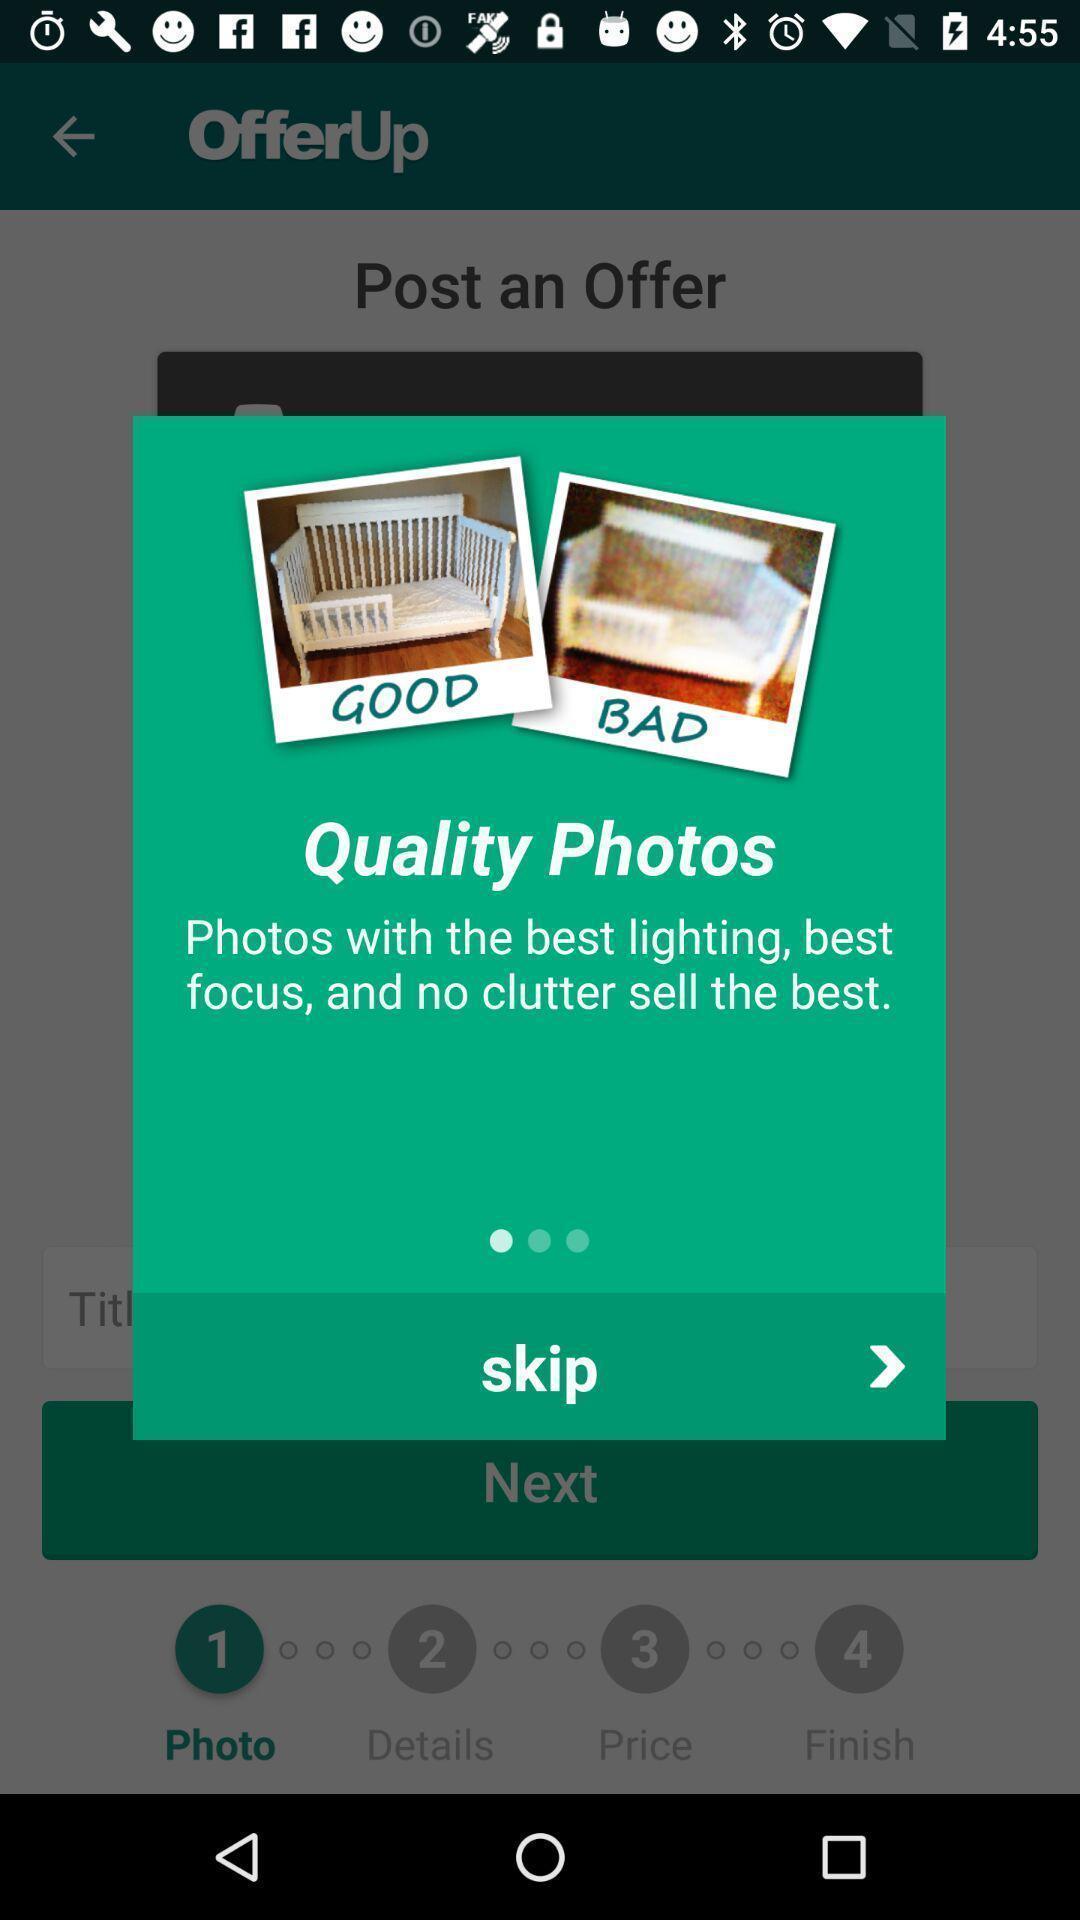Summarize the main components in this picture. Pop-up displaying to skip photo in app. 